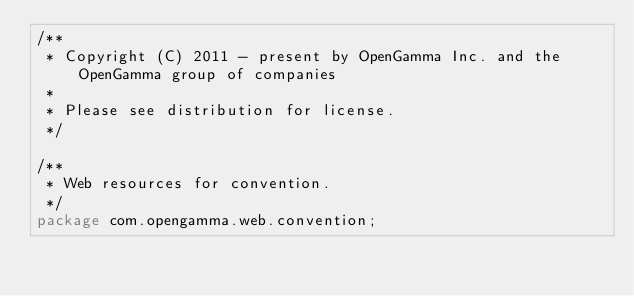Convert code to text. <code><loc_0><loc_0><loc_500><loc_500><_Java_>/**
 * Copyright (C) 2011 - present by OpenGamma Inc. and the OpenGamma group of companies
 *
 * Please see distribution for license.
 */

/**
 * Web resources for convention.
 */
package com.opengamma.web.convention;

</code> 